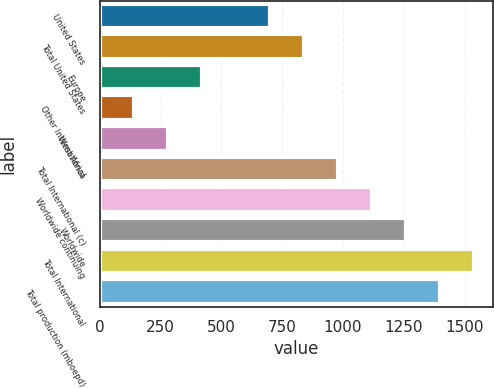Convert chart. <chart><loc_0><loc_0><loc_500><loc_500><bar_chart><fcel>United States<fcel>Total United States<fcel>Europe<fcel>Other International<fcel>West Africa<fcel>Total International (c)<fcel>Worldwide continuing<fcel>Worldwide<fcel>Total International<fcel>Total production (mboepd)<nl><fcel>700.04<fcel>840.03<fcel>420.06<fcel>140.08<fcel>280.07<fcel>980.02<fcel>1120.01<fcel>1260<fcel>1539.98<fcel>1399.99<nl></chart> 